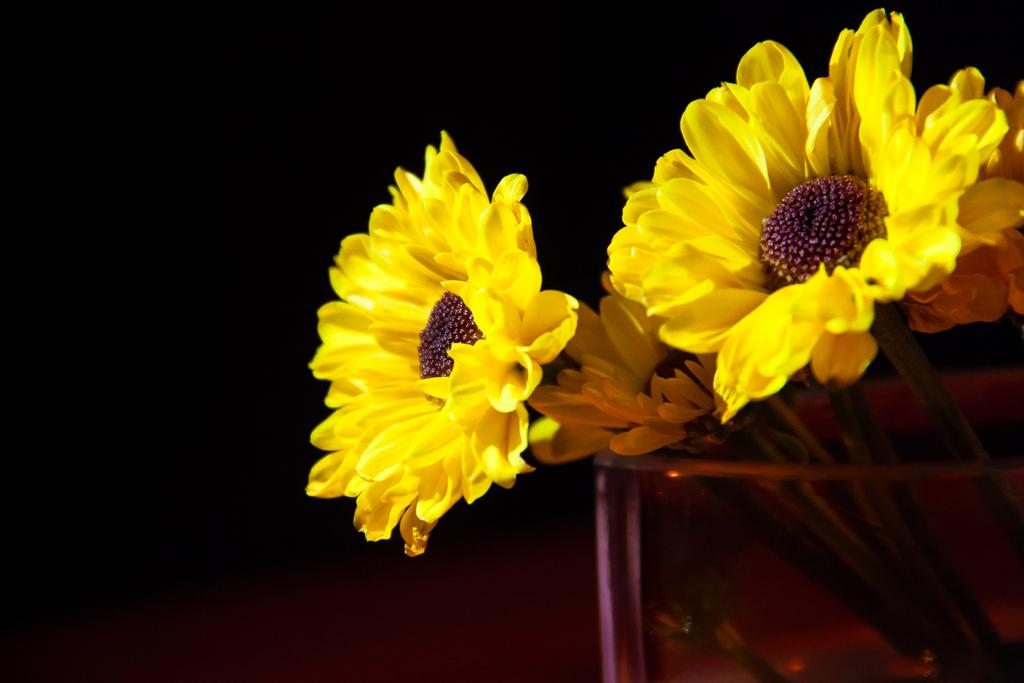What is present in the image? There are flowers in the image. How are the flowers arranged or contained? The flowers are placed in a glass. What can be observed about the lighting or color scheme of the image? The background of the image is dark. What type of attraction can be seen in the image? There is no attraction present in the image; it features flowers placed in a glass with a dark background. What color is the yarn used to decorate the flowers in the image? There is no yarn present in the image; it only features flowers in a glass with a dark background. 